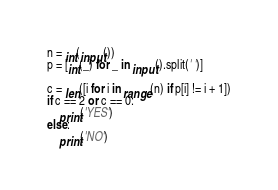<code> <loc_0><loc_0><loc_500><loc_500><_Python_>n = int(input())
p = [int(_) for _ in input().split(' ')]

c = len([i for i in range(n) if p[i] != i + 1])
if c == 2 or c == 0:
    print('YES')
else:
    print('NO')
</code> 